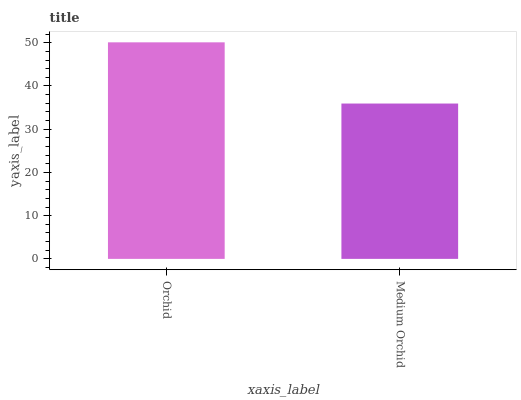Is Medium Orchid the maximum?
Answer yes or no. No. Is Orchid greater than Medium Orchid?
Answer yes or no. Yes. Is Medium Orchid less than Orchid?
Answer yes or no. Yes. Is Medium Orchid greater than Orchid?
Answer yes or no. No. Is Orchid less than Medium Orchid?
Answer yes or no. No. Is Orchid the high median?
Answer yes or no. Yes. Is Medium Orchid the low median?
Answer yes or no. Yes. Is Medium Orchid the high median?
Answer yes or no. No. Is Orchid the low median?
Answer yes or no. No. 